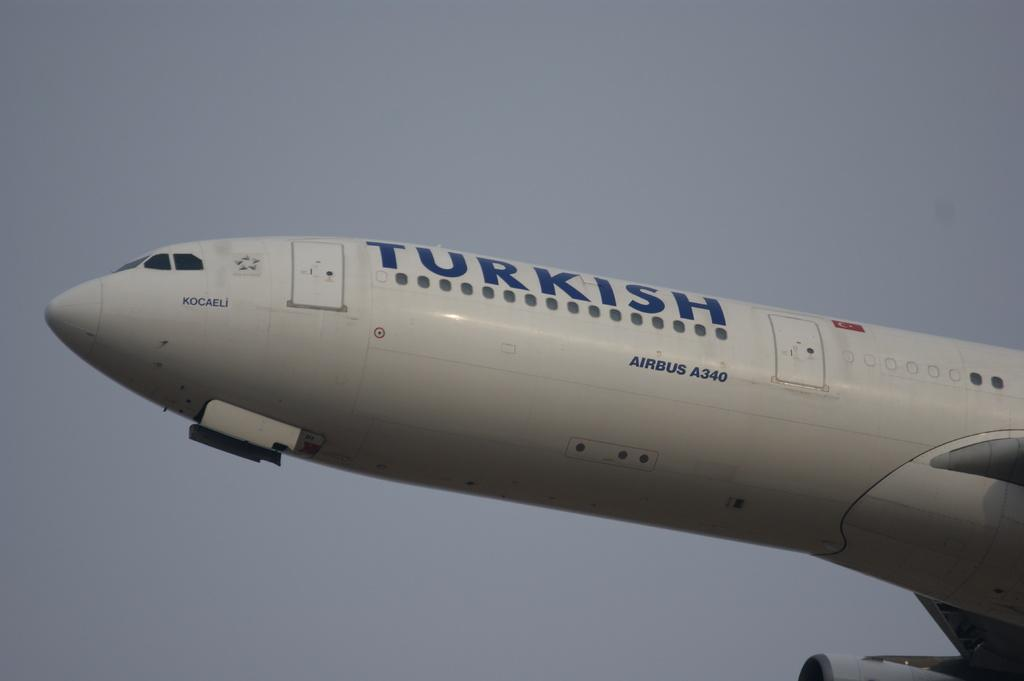<image>
Render a clear and concise summary of the photo. A white plane in the air with Turkish written on it 